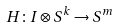Convert formula to latex. <formula><loc_0><loc_0><loc_500><loc_500>H \colon I \otimes S ^ { k } \rightarrow S ^ { m }</formula> 